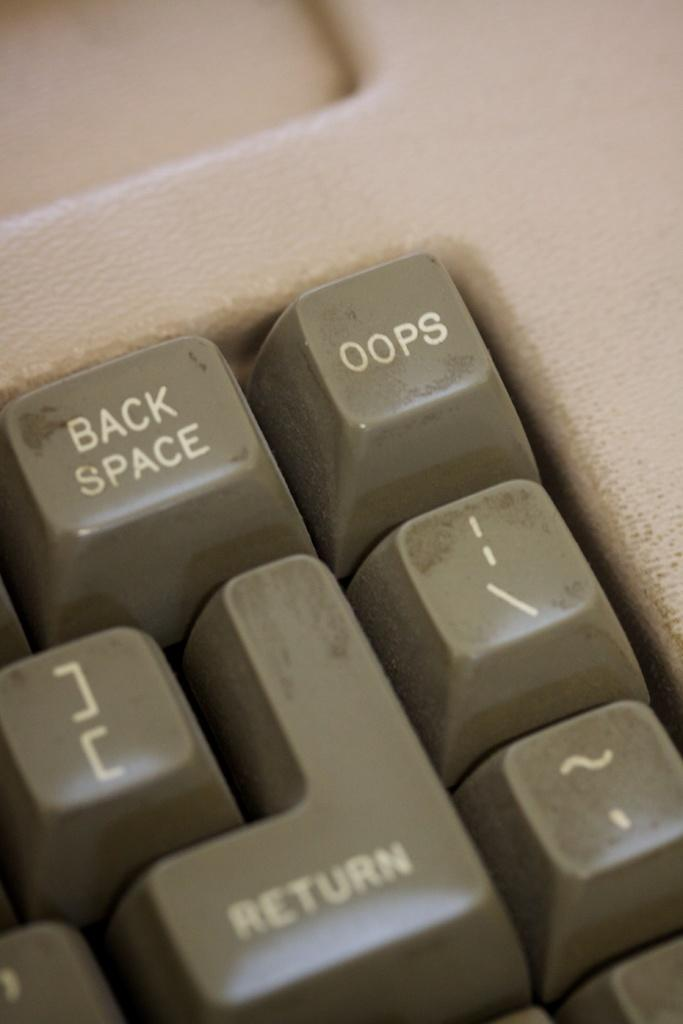<image>
Describe the image concisely. a keyboard with a key on the top right corner that says 'oops' 